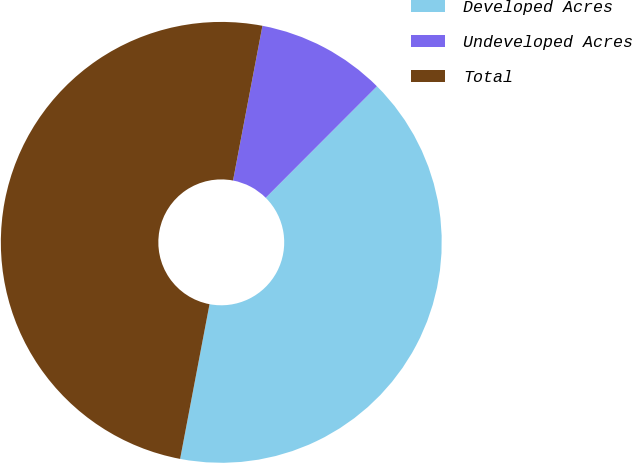Convert chart to OTSL. <chart><loc_0><loc_0><loc_500><loc_500><pie_chart><fcel>Developed Acres<fcel>Undeveloped Acres<fcel>Total<nl><fcel>40.51%<fcel>9.49%<fcel>50.0%<nl></chart> 